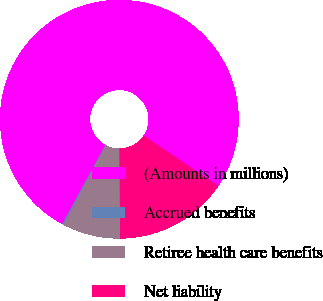Convert chart to OTSL. <chart><loc_0><loc_0><loc_500><loc_500><pie_chart><fcel>(Amounts in millions)<fcel>Accrued benefits<fcel>Retiree health care benefits<fcel>Net liability<nl><fcel>76.49%<fcel>0.21%<fcel>7.84%<fcel>15.47%<nl></chart> 